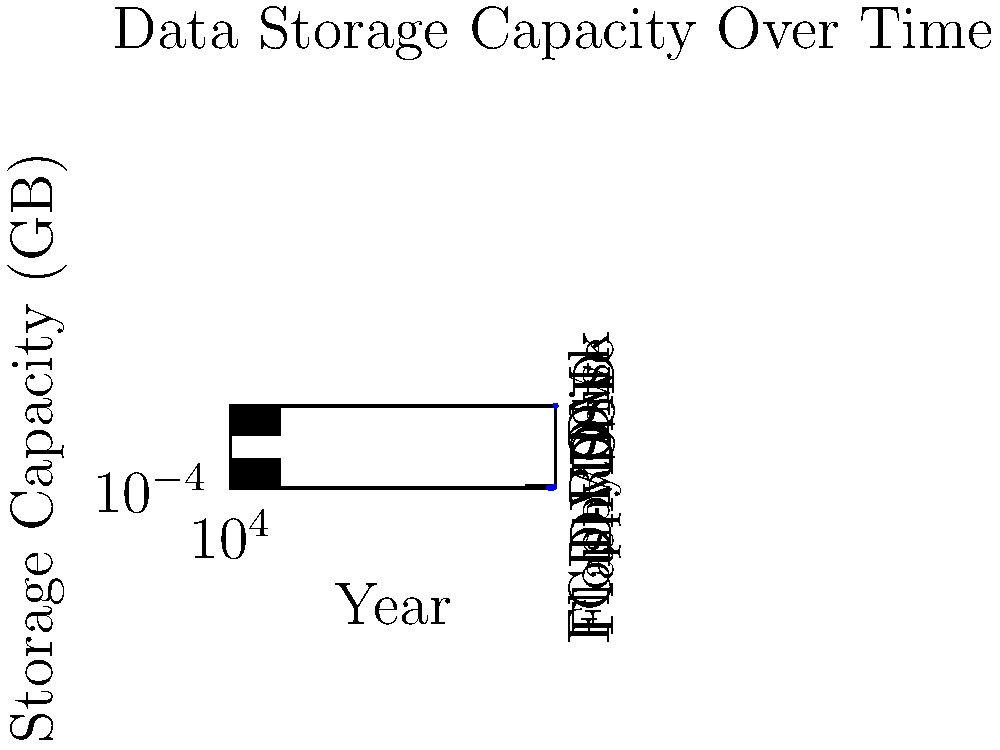Based on the graph showing the increase in data storage capacity over time, approximately how many times larger is the storage capacity of an SSD in 2020 compared to a DVD in 2000? To solve this question, we need to follow these steps:

1. Identify the storage capacity for DVD in 2000:
   From the graph, we can see that DVD in 2000 had a storage capacity of 1 GB.

2. Identify the storage capacity for SSD in 2020:
   The graph shows that SSD in 2020 had a storage capacity of 10,000 GB.

3. Calculate the ratio between SSD (2020) and DVD (2000) capacities:
   Ratio = SSD capacity / DVD capacity
   Ratio = 10,000 GB / 1 GB = 10,000

Therefore, the storage capacity of an SSD in 2020 is approximately 10,000 times larger than a DVD in 2000.

This dramatic increase in storage capacity demonstrates the rapid advancement in data storage technology over just two decades, which has significant implications for how we store and access information in our daily lives.
Answer: 10,000 times 